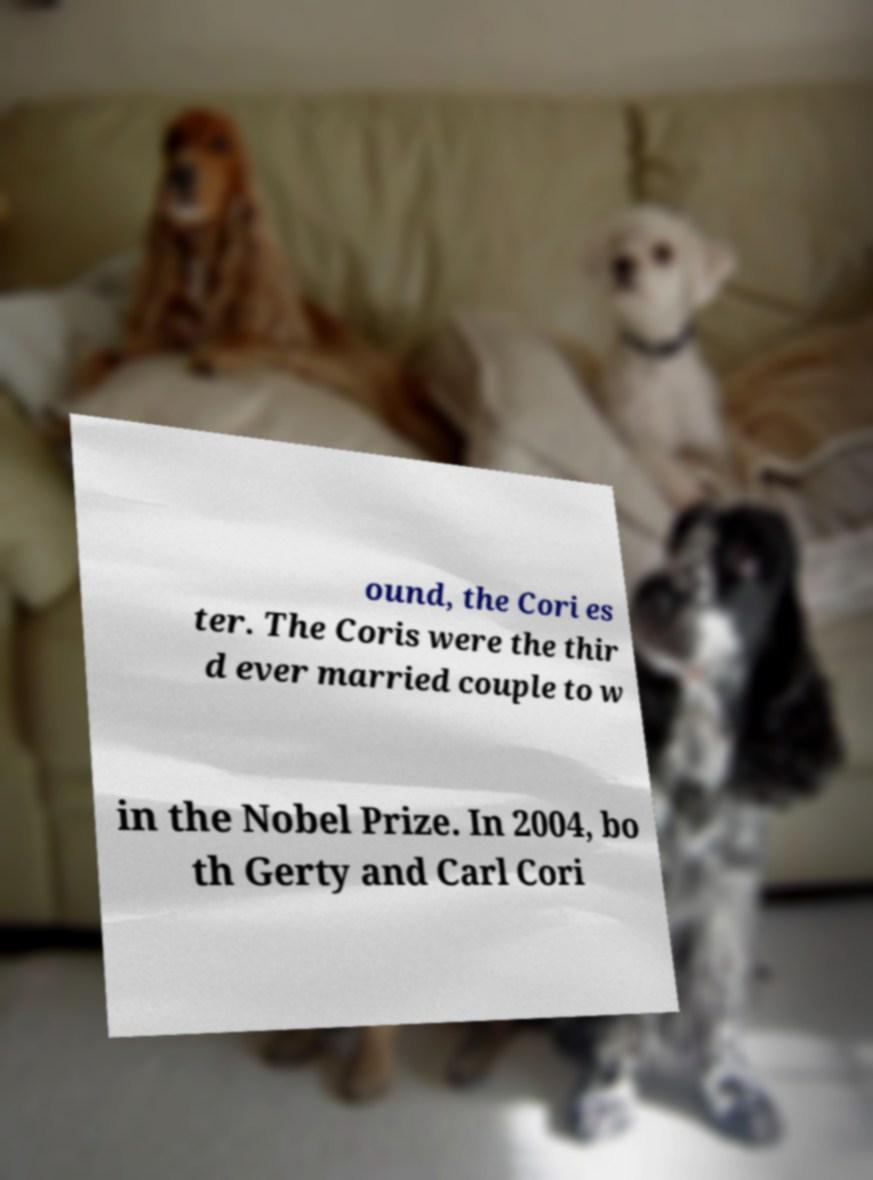Can you read and provide the text displayed in the image?This photo seems to have some interesting text. Can you extract and type it out for me? ound, the Cori es ter. The Coris were the thir d ever married couple to w in the Nobel Prize. In 2004, bo th Gerty and Carl Cori 